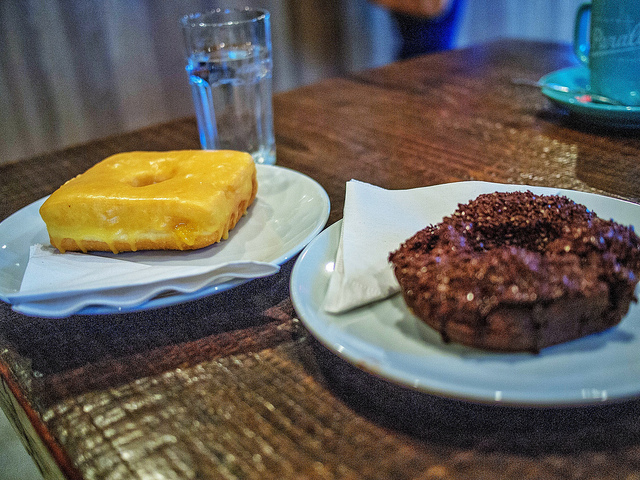Describe the setting in which these donuts are being served. The donuts are presented on simple ceramic plates, suggesting a casual, cozy setting, perhaps a local café or a homely kitchen where one can relax and savor these treats. 